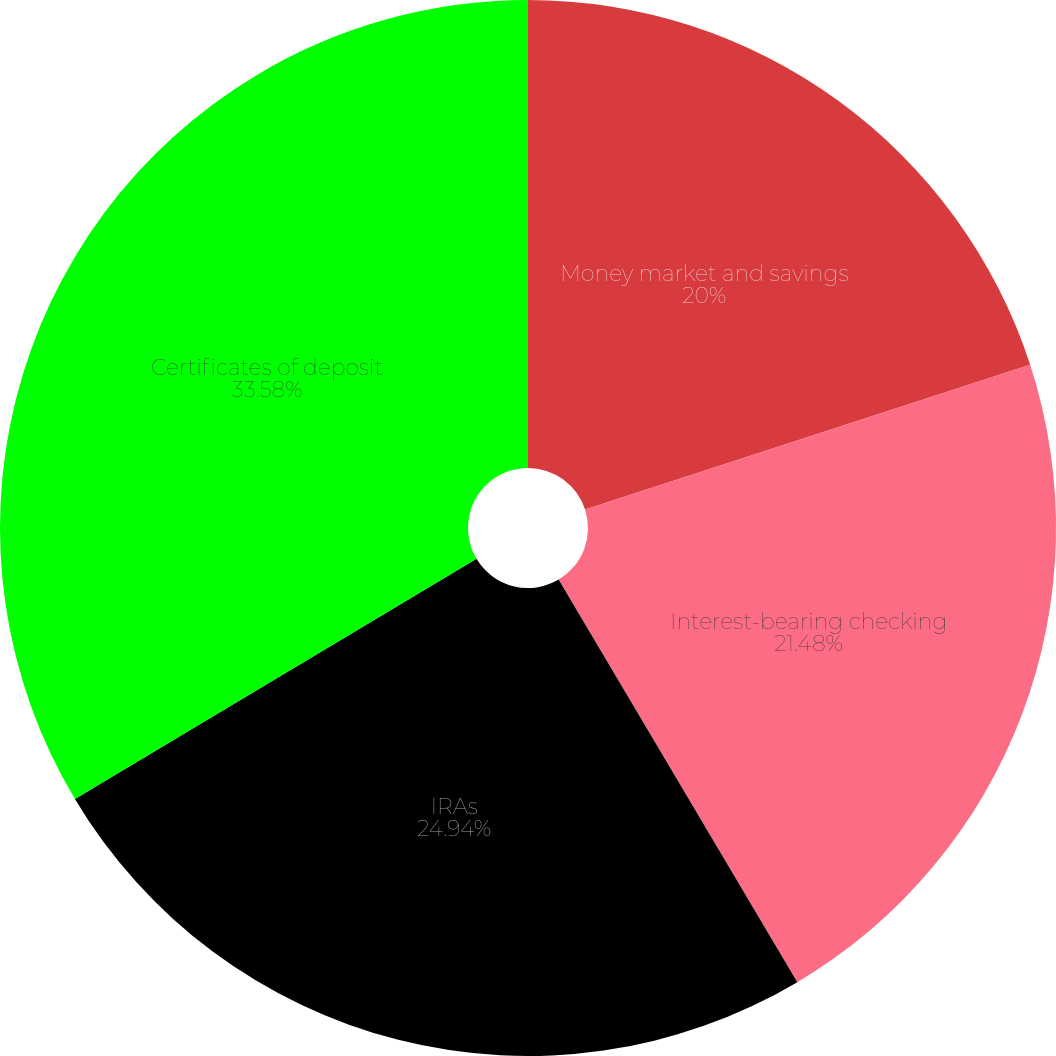Convert chart. <chart><loc_0><loc_0><loc_500><loc_500><pie_chart><fcel>Money market and savings<fcel>Interest-bearing checking<fcel>IRAs<fcel>Certificates of deposit<nl><fcel>20.0%<fcel>21.48%<fcel>24.94%<fcel>33.58%<nl></chart> 